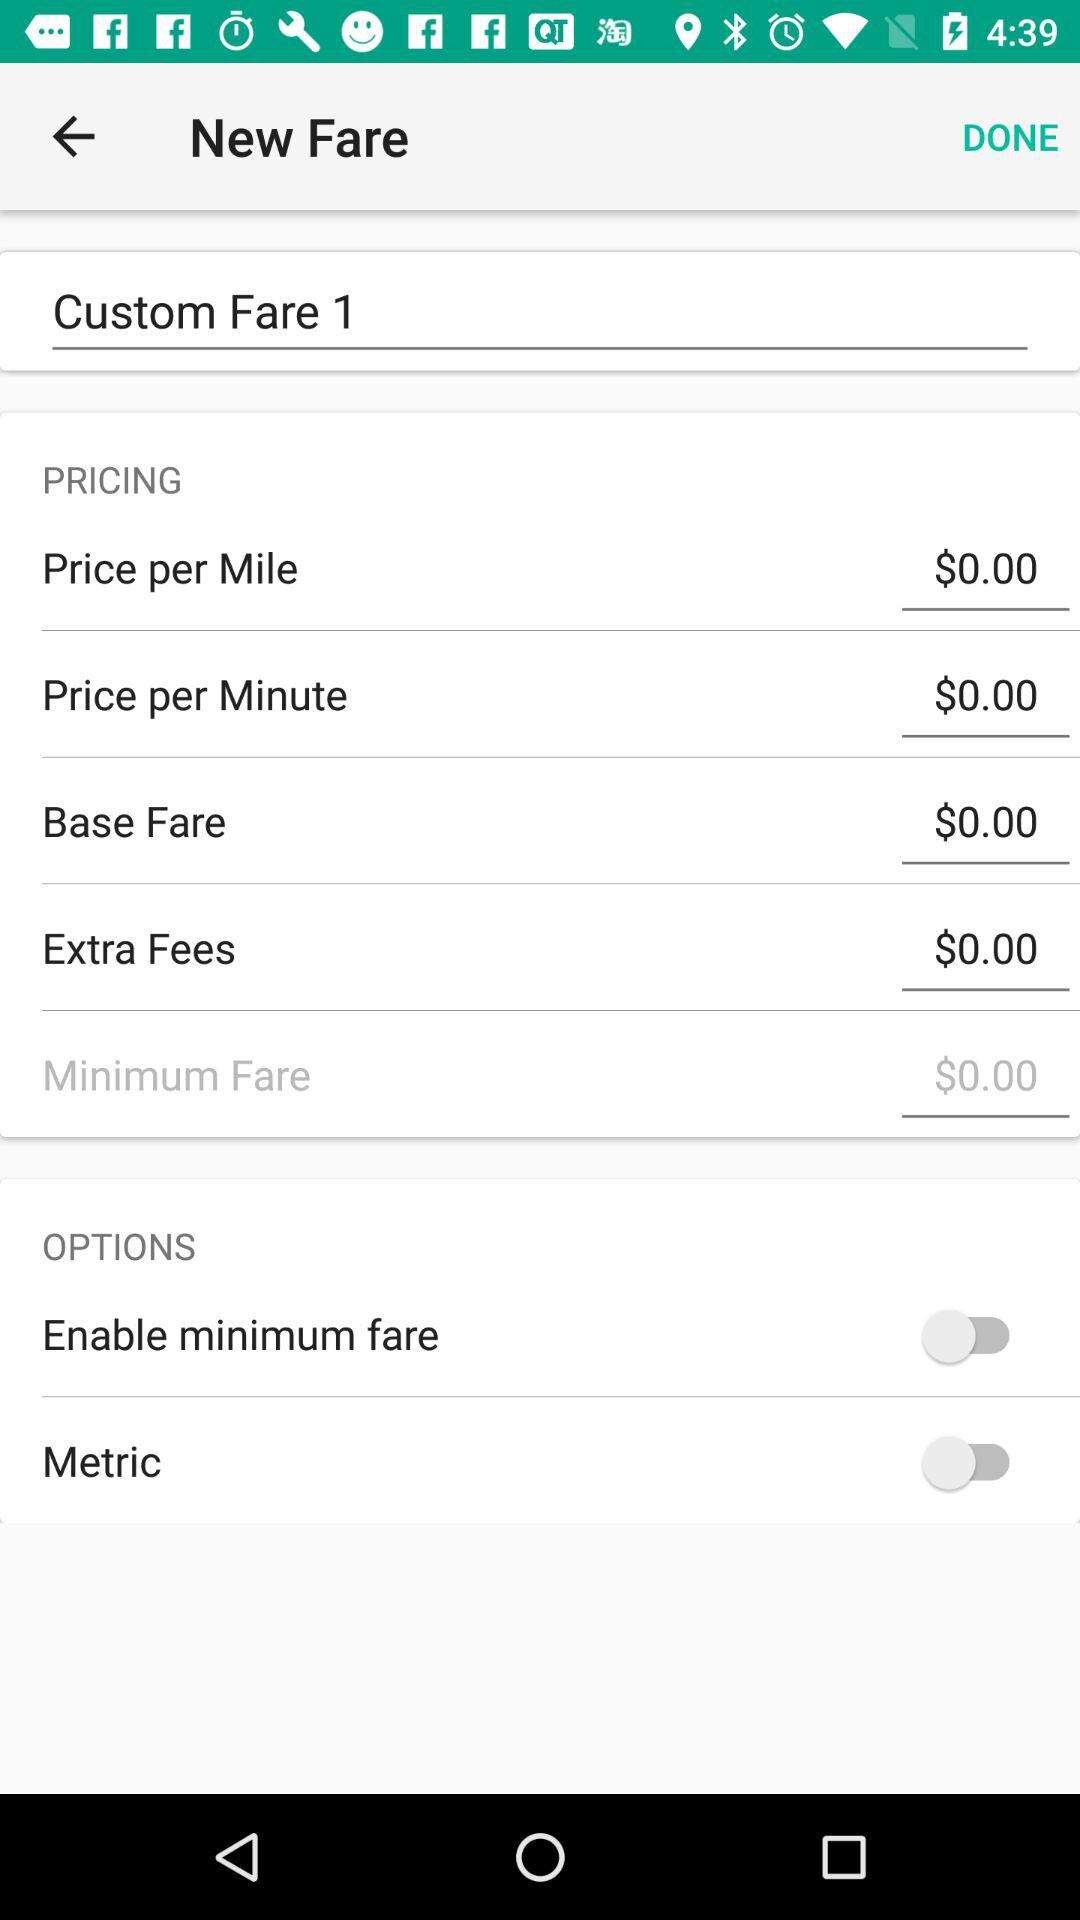What is the amount of the extra fees? The amount of the extra fees is $0. 